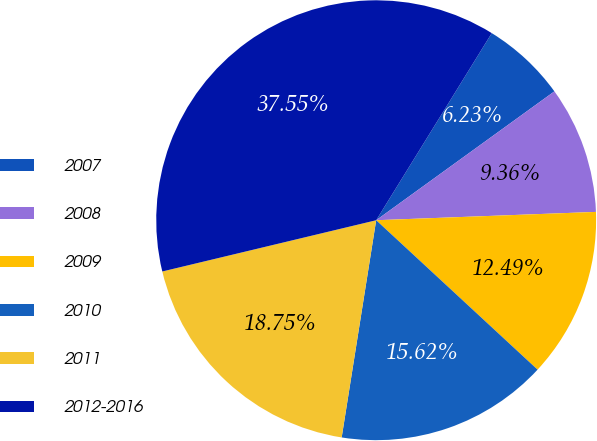<chart> <loc_0><loc_0><loc_500><loc_500><pie_chart><fcel>2007<fcel>2008<fcel>2009<fcel>2010<fcel>2011<fcel>2012-2016<nl><fcel>6.23%<fcel>9.36%<fcel>12.49%<fcel>15.62%<fcel>18.75%<fcel>37.55%<nl></chart> 